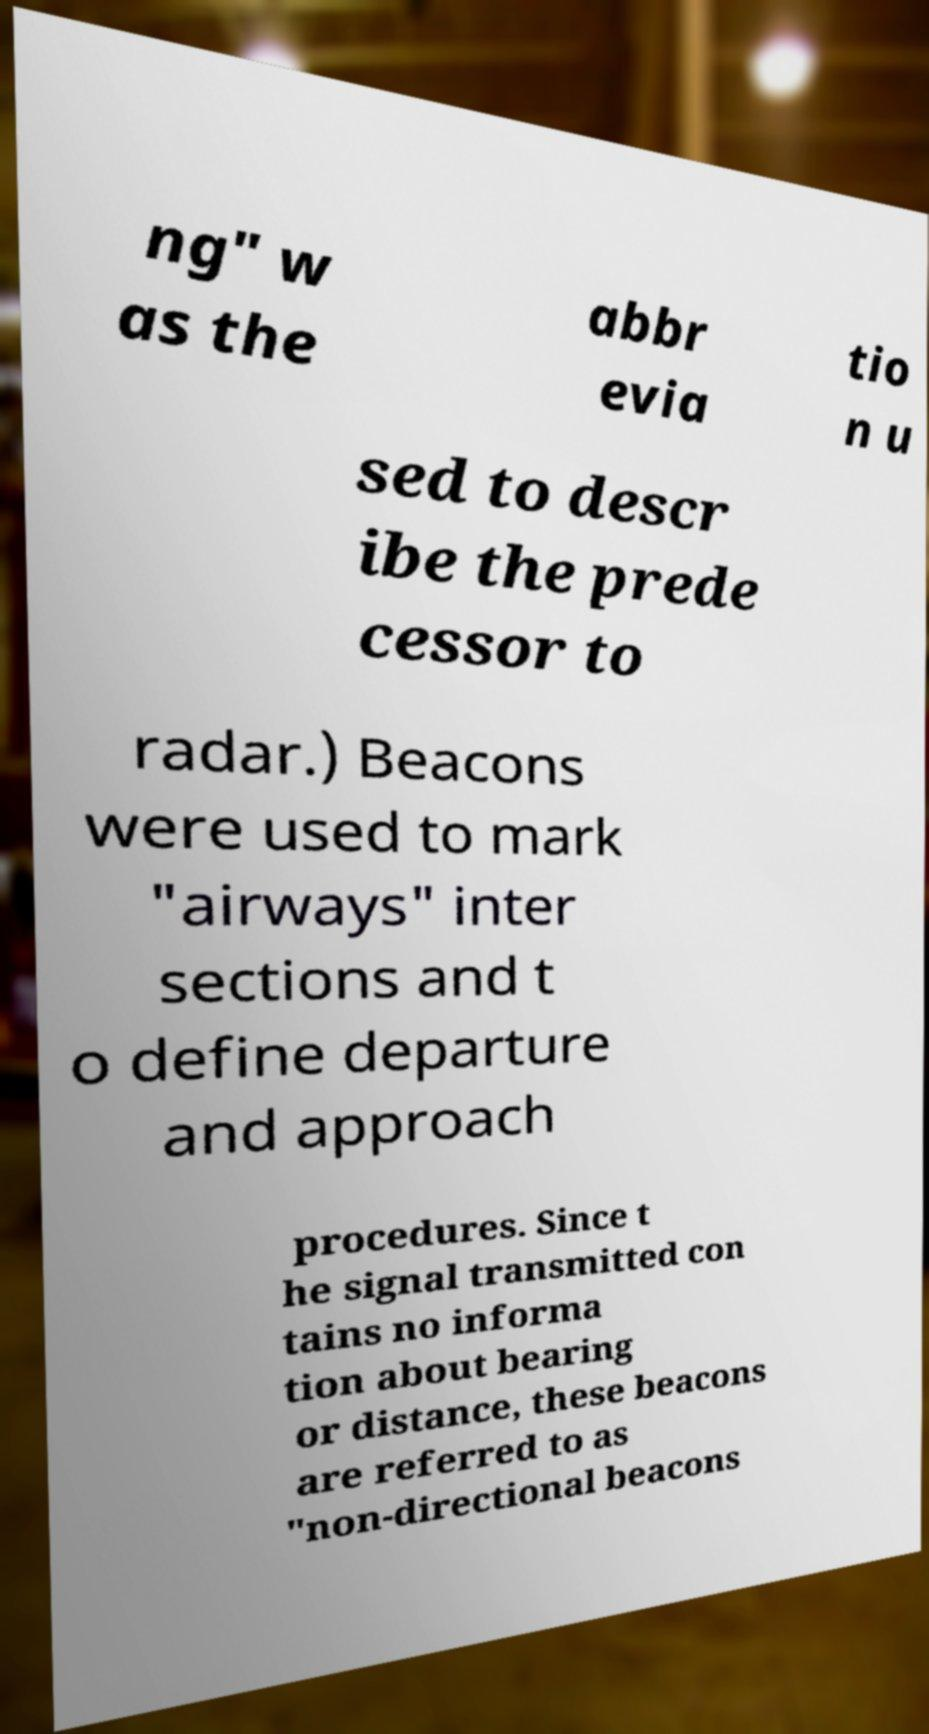Could you extract and type out the text from this image? ng" w as the abbr evia tio n u sed to descr ibe the prede cessor to radar.) Beacons were used to mark "airways" inter sections and t o define departure and approach procedures. Since t he signal transmitted con tains no informa tion about bearing or distance, these beacons are referred to as "non-directional beacons 